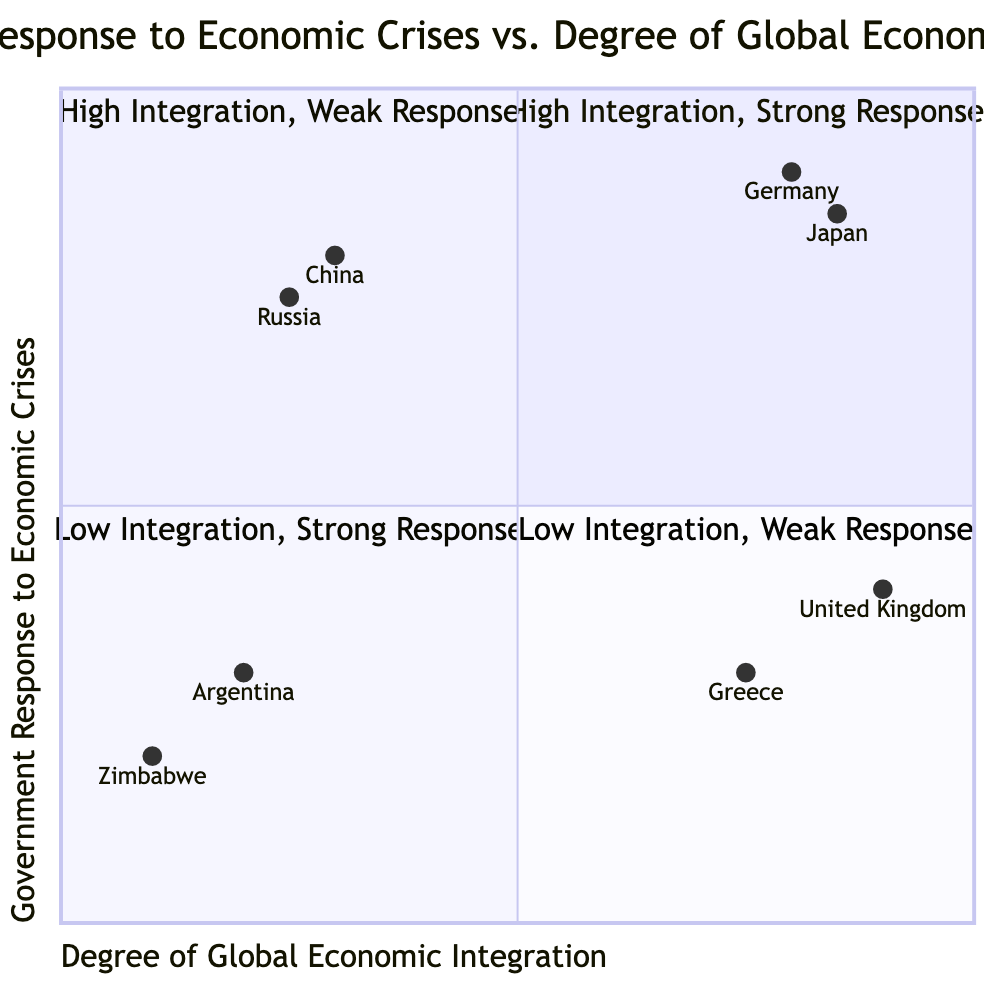What countries are in the High Integration, Strong Response quadrant? The High Integration, Strong Response quadrant, labeled as Q1, contains two countries: Germany and Japan.
Answer: Germany, Japan What was Germany's response to the 2008 Global Financial Crisis? In the diagram, Germany's response is noted as "Significant fiscal stimulus and bailouts."
Answer: Significant fiscal stimulus and bailouts Which country has the weakest response in the Low Integration quadrant? The Low Integration, Weak Response quadrant, labeled as Q4, contains Zimbabwe and Argentina. Among these, Zimbabwe is listed with "Limited and ineffective government intervention," indicating a weaker response.
Answer: Zimbabwe How many countries are represented in the High Integration, Weak Response quadrant? The High Integration, Weak Response quadrant, labeled as Q2, includes two countries: Greece and the United Kingdom.
Answer: 2 Which country in the Low Integration, Strong Response quadrant responded to the 1997 Asian Financial Crisis? The response to the 1997 Asian Financial Crisis in the Low Integration, Strong Response quadrant, labeled as Q3, is attributed to China, which implemented "Large-scale fiscal stimulus and reforms."
Answer: China Why did Greece have a weak response during the European Debt Crisis? Greece, in the High Integration, Weak Response quadrant, had an economic crisis response centered around "Austerity measures and EU-imposed conditions," which indicates limited governmental flexibility due to external pressures.
Answer: Austerity measures and EU-imposed conditions Which country demonstrated the highest degree of global economic integration with a strong response? The country with the highest degree of global economic integration is Japan, which is positioned high on the x-axis and has a significant response marked in Q1.
Answer: Japan In which quadrant is Russia located, and what was its response during the 1998 Russian Financial Crisis? Russia is located in the Low Integration, Strong Response quadrant (Q3) with a response that emphasizes "State intervention and strategic sector support."
Answer: Low Integration, Strong Response; State intervention and strategic sector support 